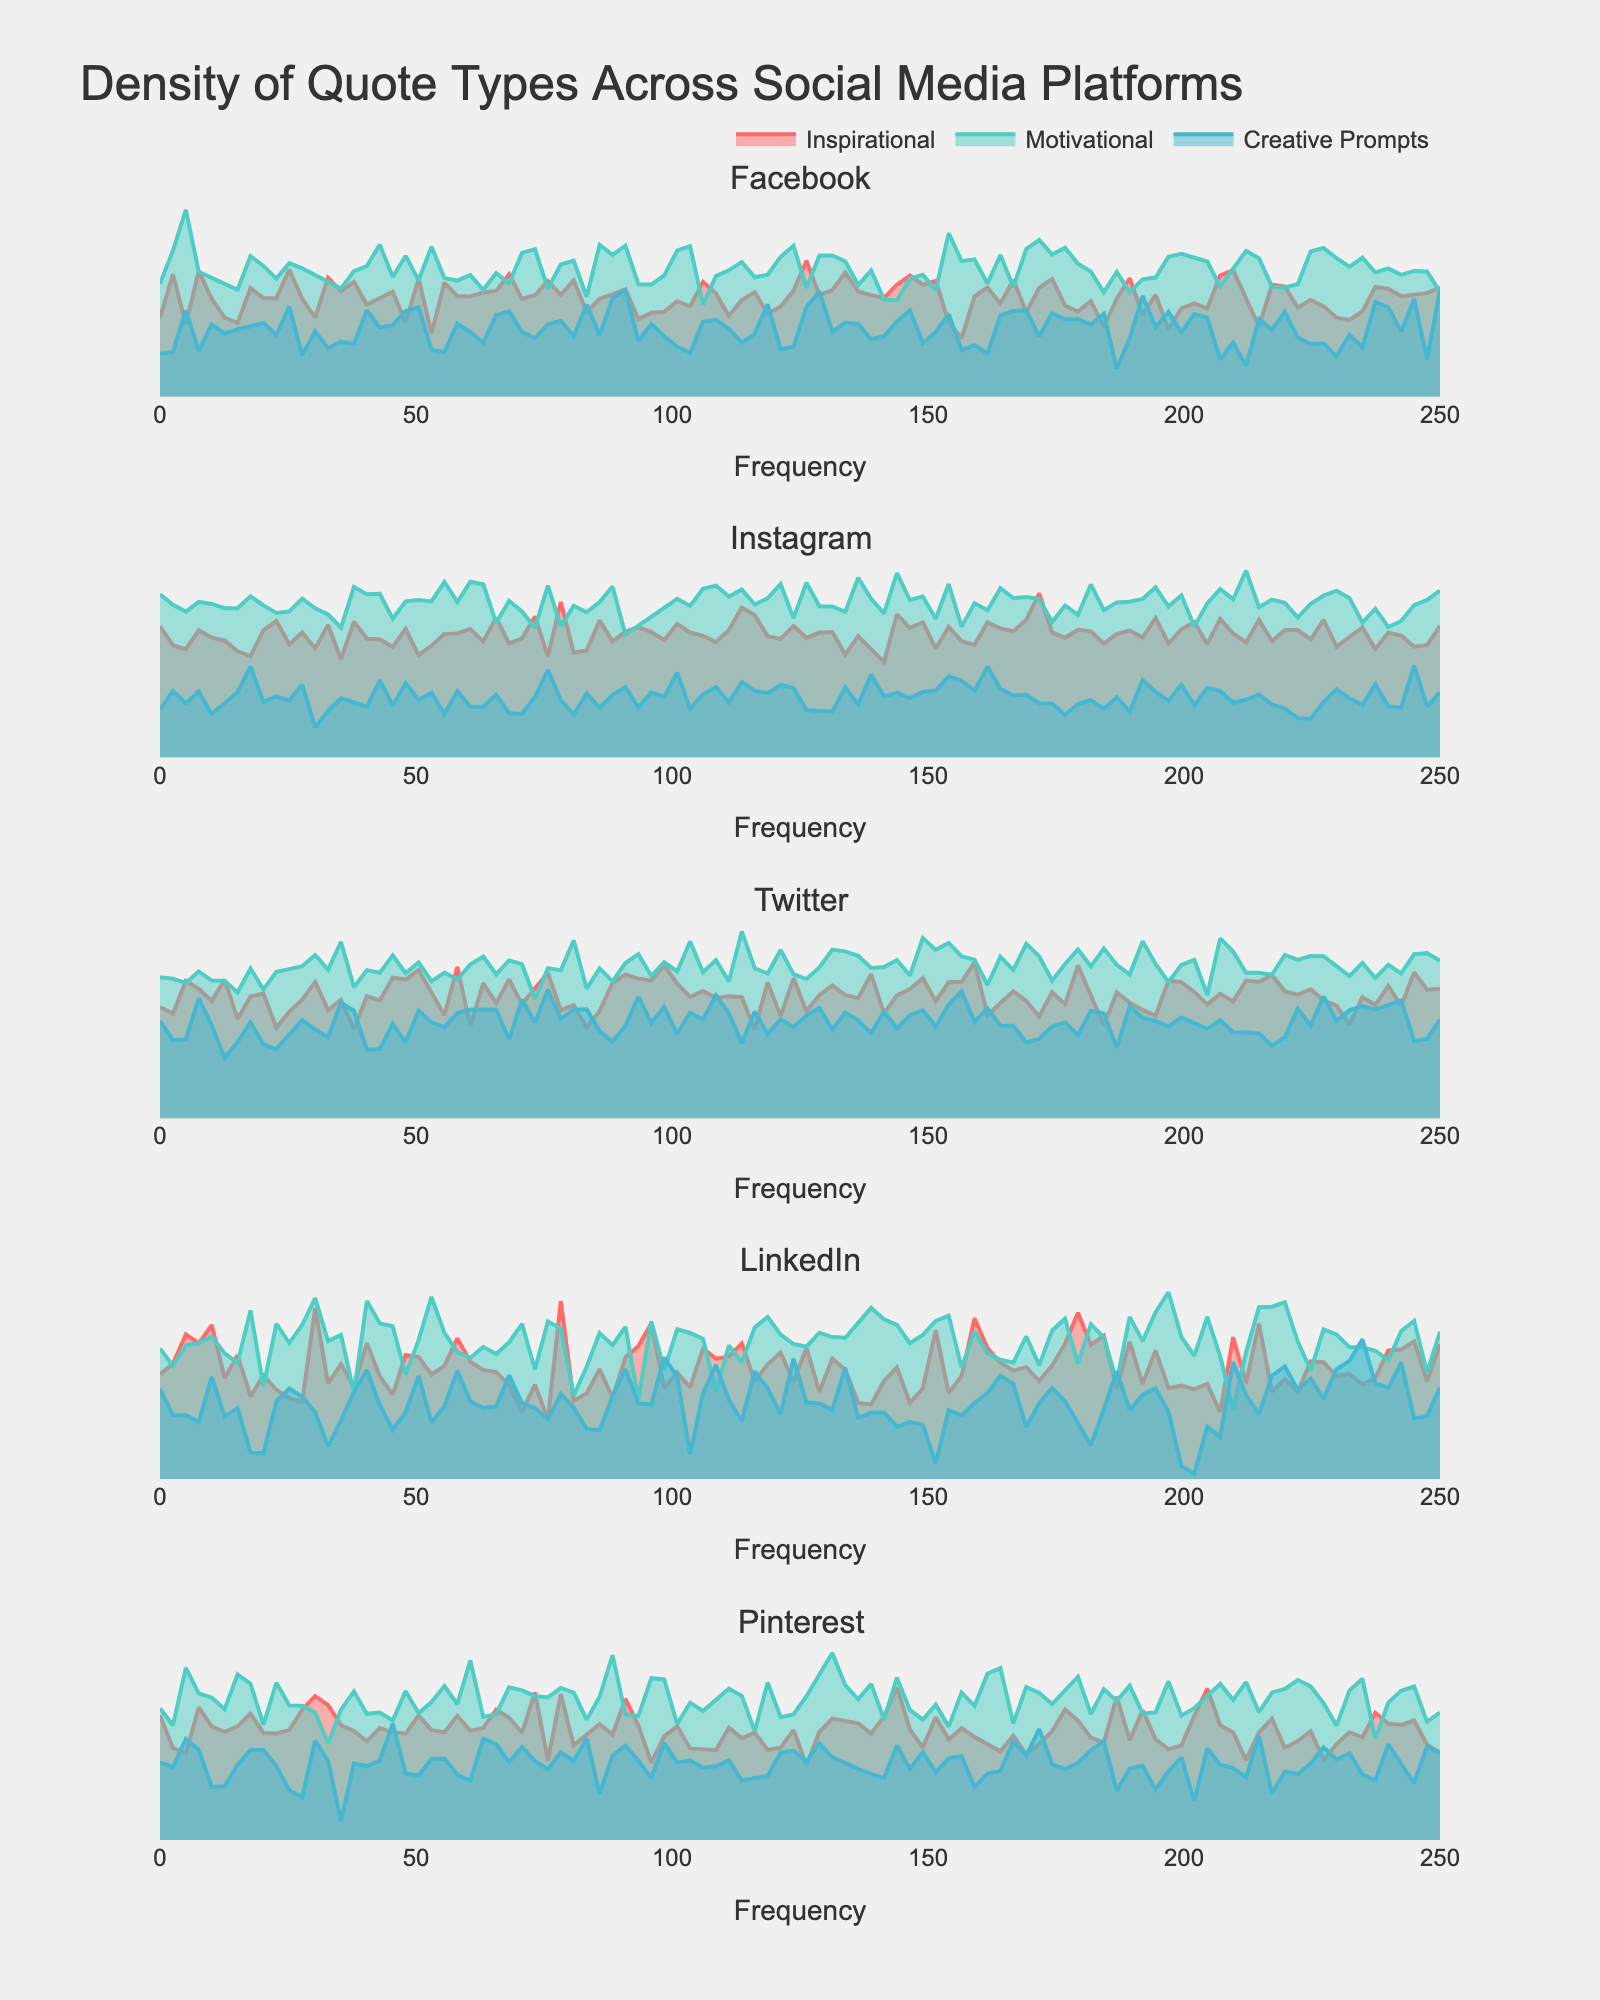What is the title of the figure? The title is located at the top of the figure, it is usually the largest text element and designed to be descriptive.
Answer: Density of Quote Types Across Social Media Platforms How many total social media platforms are represented in the figure? Count the number of subplot titles, which correspond to the different social media platforms represented.
Answer: 5 Which platform has the highest frequency of Inspirational quotes? By observing the peak highest density line for Inspirational quotes on each platform's subplot (which could be identified based on colors per the legend), we can compare which one reaches the highest frequency.
Answer: Instagram What is the frequency range for Creative Prompts quotes on Twitter? By analyzing the density plot for Twitter's Creative Prompts, notice the highest and the lowest values on the x-axis where the density plot exists.
Answer: Approximately 0 to 140 How does the density of Motivational quotes on Facebook compare to Twitter? Compare the density peaks and shapes of Motivational quotes (using color reference) between the subplots for Facebook and Twitter. Look for differences in peak height and width spread across the x-axis.
Answer: Twitter has a higher peak density and broader spread Which quote type has the broadest spread in frequency on Pinterest? Look at Pinterest's subplot and identify which density plot (as per legend's color) spans the widest range on the x-axis.
Answer: Motivational What can you say about the average frequency of Motivational quotes across all platforms? For this, one would visually estimate the central tendency (average) of the density peaks of Motivational quotes, considering each subplot and averaging their peaks. Instagram and Twitter seem to have higher peaks contributing to a potentially higher average.
Answer: Higher on Instagram and Twitter, moderate on Facebook and Pinterest, lower on LinkedIn Which platform shows the lowest density of quotes for any category? Identify the subplot where all density plots remain consistently low, hence check the overall lower density atmosphere.
Answer: LinkedIn How does the density spread of Instagram's Motivational quotes compare to Facebook's? Observe how wide the x-axis spread is for each platform's density plot regarding Motivational quotes and where the peaks are concentrated to note if Instagram's spread is wider, narrower, or similar.
Answer: Instagram's spread is wider and reaches higher frequencies than Facebook's What is the visual pattern observed across different platforms for Creative Prompts quotes? Look for consistent visual features—the density (height of the peaks), range (spread of the quotes on x-axis), and shape (symmetry or skewness of the distribution) of Creative Prompts across all subplots.
Answer: Less dense, fairly uniform with the peak height, moderate spread 